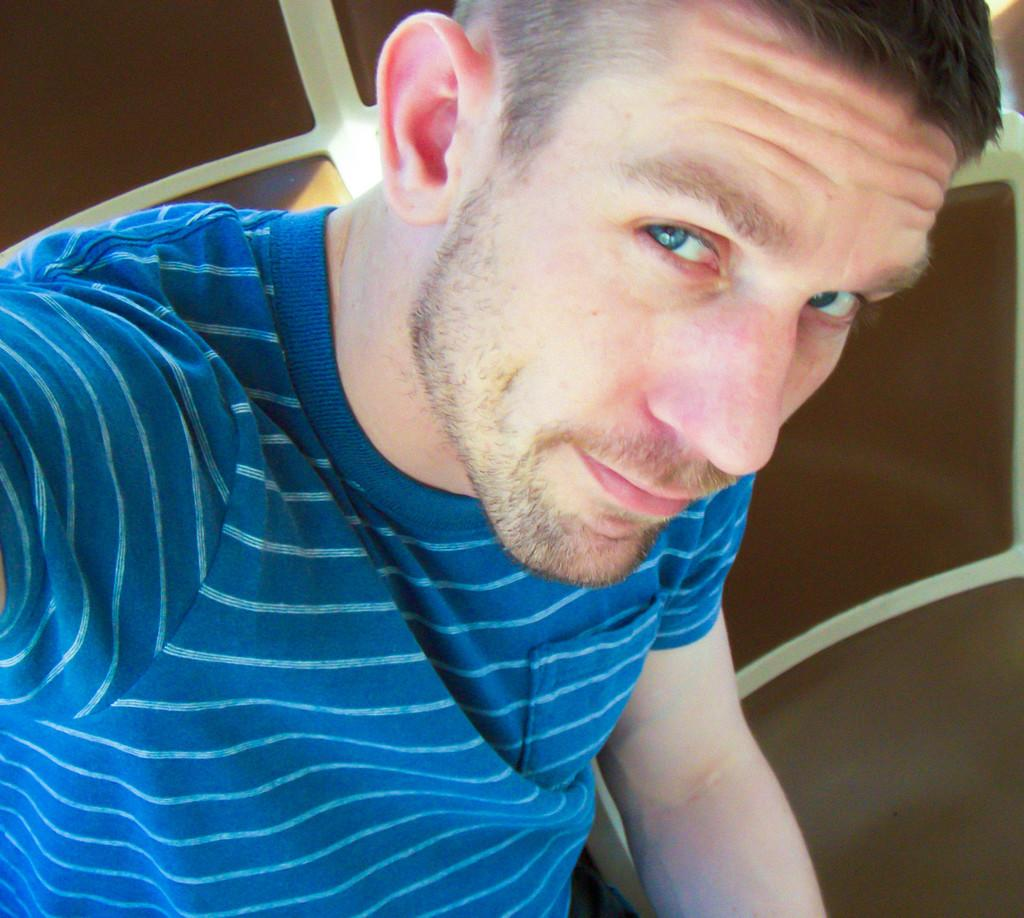Who is present in the image? There is a man in the image. What is the man doing in the image? The man is seated in a chair. What is the man wearing in the image? The man is wearing a blue t-shirt. Are there any other chairs visible in the image? Yes, there is another chair visible in the image. What type of payment system is the man using in the image? There is no payment system present in the image; the man is simply seated in a chair. 